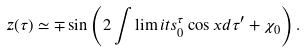Convert formula to latex. <formula><loc_0><loc_0><loc_500><loc_500>z ( \tau ) \simeq \mp \sin \left ( 2 \int \lim i t s _ { 0 } ^ { \tau } \cos x d \tau ^ { \prime } + \chi _ { 0 } \right ) .</formula> 